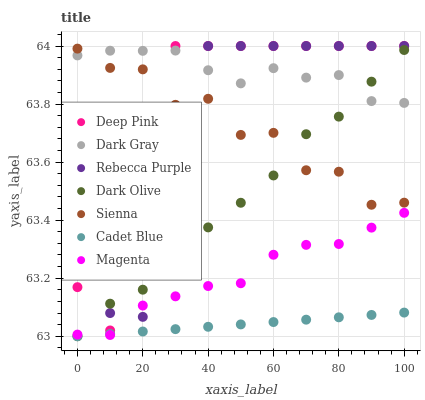Does Cadet Blue have the minimum area under the curve?
Answer yes or no. Yes. Does Dark Gray have the maximum area under the curve?
Answer yes or no. Yes. Does Deep Pink have the minimum area under the curve?
Answer yes or no. No. Does Deep Pink have the maximum area under the curve?
Answer yes or no. No. Is Cadet Blue the smoothest?
Answer yes or no. Yes. Is Rebecca Purple the roughest?
Answer yes or no. Yes. Is Deep Pink the smoothest?
Answer yes or no. No. Is Deep Pink the roughest?
Answer yes or no. No. Does Dark Olive have the lowest value?
Answer yes or no. Yes. Does Deep Pink have the lowest value?
Answer yes or no. No. Does Rebecca Purple have the highest value?
Answer yes or no. Yes. Does Dark Olive have the highest value?
Answer yes or no. No. Is Magenta less than Sienna?
Answer yes or no. Yes. Is Deep Pink greater than Magenta?
Answer yes or no. Yes. Does Deep Pink intersect Sienna?
Answer yes or no. Yes. Is Deep Pink less than Sienna?
Answer yes or no. No. Is Deep Pink greater than Sienna?
Answer yes or no. No. Does Magenta intersect Sienna?
Answer yes or no. No. 